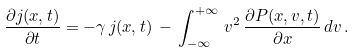Convert formula to latex. <formula><loc_0><loc_0><loc_500><loc_500>\frac { \partial j ( x , t ) } { \partial t } = - \gamma \, j ( x , t ) \, - \, \int _ { - \infty } ^ { + \infty } \, v ^ { 2 } \, \frac { \partial P ( x , v , t ) } { \partial x } \, d v \, .</formula> 